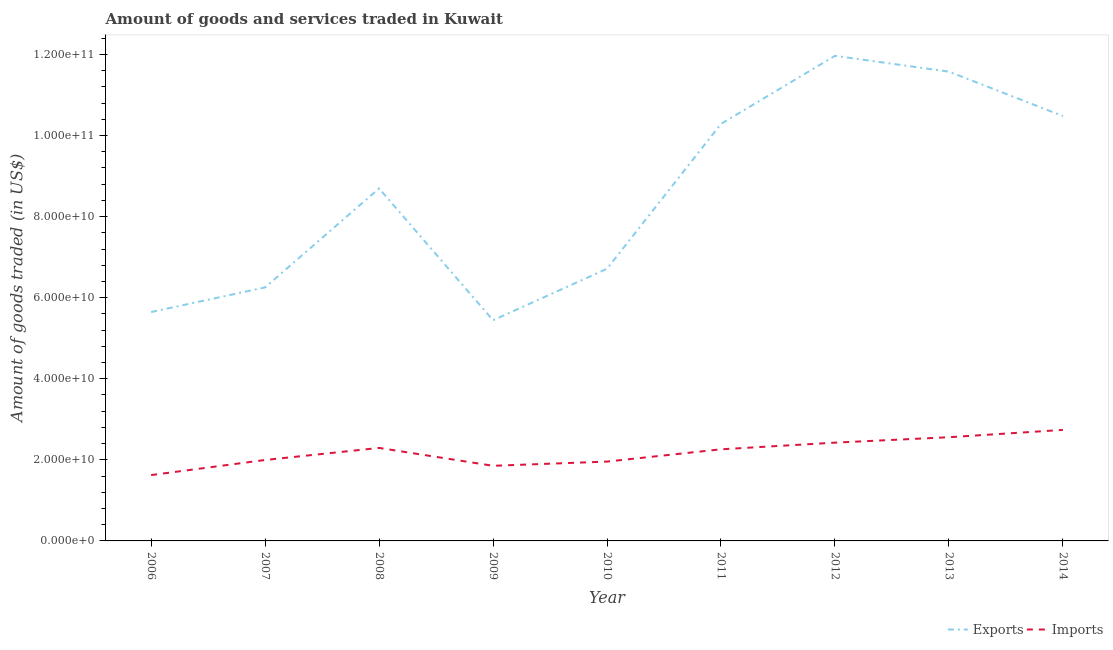How many different coloured lines are there?
Offer a very short reply. 2. Does the line corresponding to amount of goods exported intersect with the line corresponding to amount of goods imported?
Make the answer very short. No. What is the amount of goods imported in 2007?
Your answer should be very brief. 2.00e+1. Across all years, what is the maximum amount of goods exported?
Provide a short and direct response. 1.20e+11. Across all years, what is the minimum amount of goods imported?
Offer a very short reply. 1.62e+1. In which year was the amount of goods exported minimum?
Offer a very short reply. 2009. What is the total amount of goods imported in the graph?
Make the answer very short. 1.97e+11. What is the difference between the amount of goods imported in 2010 and that in 2011?
Offer a very short reply. -3.03e+09. What is the difference between the amount of goods exported in 2007 and the amount of goods imported in 2006?
Give a very brief answer. 4.63e+1. What is the average amount of goods exported per year?
Give a very brief answer. 8.56e+1. In the year 2014, what is the difference between the amount of goods imported and amount of goods exported?
Offer a very short reply. -7.74e+1. In how many years, is the amount of goods imported greater than 4000000000 US$?
Your answer should be very brief. 9. What is the ratio of the amount of goods imported in 2011 to that in 2012?
Provide a short and direct response. 0.93. What is the difference between the highest and the second highest amount of goods imported?
Provide a succinct answer. 1.81e+09. What is the difference between the highest and the lowest amount of goods exported?
Provide a short and direct response. 6.52e+1. In how many years, is the amount of goods exported greater than the average amount of goods exported taken over all years?
Make the answer very short. 5. Does the amount of goods exported monotonically increase over the years?
Make the answer very short. No. How many lines are there?
Offer a terse response. 2. Does the graph contain any zero values?
Keep it short and to the point. No. How many legend labels are there?
Your response must be concise. 2. How are the legend labels stacked?
Offer a terse response. Horizontal. What is the title of the graph?
Keep it short and to the point. Amount of goods and services traded in Kuwait. What is the label or title of the Y-axis?
Keep it short and to the point. Amount of goods traded (in US$). What is the Amount of goods traded (in US$) in Exports in 2006?
Ensure brevity in your answer.  5.65e+1. What is the Amount of goods traded (in US$) of Imports in 2006?
Provide a short and direct response. 1.62e+1. What is the Amount of goods traded (in US$) in Exports in 2007?
Make the answer very short. 6.25e+1. What is the Amount of goods traded (in US$) of Imports in 2007?
Your answer should be compact. 2.00e+1. What is the Amount of goods traded (in US$) of Exports in 2008?
Offer a very short reply. 8.69e+1. What is the Amount of goods traded (in US$) of Imports in 2008?
Give a very brief answer. 2.29e+1. What is the Amount of goods traded (in US$) in Exports in 2009?
Your answer should be very brief. 5.44e+1. What is the Amount of goods traded (in US$) in Imports in 2009?
Make the answer very short. 1.85e+1. What is the Amount of goods traded (in US$) of Exports in 2010?
Provide a short and direct response. 6.71e+1. What is the Amount of goods traded (in US$) of Imports in 2010?
Your response must be concise. 1.96e+1. What is the Amount of goods traded (in US$) of Exports in 2011?
Your answer should be compact. 1.03e+11. What is the Amount of goods traded (in US$) of Imports in 2011?
Provide a short and direct response. 2.26e+1. What is the Amount of goods traded (in US$) in Exports in 2012?
Your answer should be very brief. 1.20e+11. What is the Amount of goods traded (in US$) in Imports in 2012?
Keep it short and to the point. 2.42e+1. What is the Amount of goods traded (in US$) of Exports in 2013?
Give a very brief answer. 1.16e+11. What is the Amount of goods traded (in US$) of Imports in 2013?
Offer a terse response. 2.56e+1. What is the Amount of goods traded (in US$) of Exports in 2014?
Your answer should be compact. 1.05e+11. What is the Amount of goods traded (in US$) of Imports in 2014?
Your answer should be very brief. 2.74e+1. Across all years, what is the maximum Amount of goods traded (in US$) of Exports?
Offer a terse response. 1.20e+11. Across all years, what is the maximum Amount of goods traded (in US$) in Imports?
Provide a short and direct response. 2.74e+1. Across all years, what is the minimum Amount of goods traded (in US$) in Exports?
Your answer should be compact. 5.44e+1. Across all years, what is the minimum Amount of goods traded (in US$) of Imports?
Make the answer very short. 1.62e+1. What is the total Amount of goods traded (in US$) in Exports in the graph?
Your answer should be compact. 7.71e+11. What is the total Amount of goods traded (in US$) in Imports in the graph?
Give a very brief answer. 1.97e+11. What is the difference between the Amount of goods traded (in US$) of Exports in 2006 and that in 2007?
Keep it short and to the point. -6.07e+09. What is the difference between the Amount of goods traded (in US$) in Imports in 2006 and that in 2007?
Ensure brevity in your answer.  -3.72e+09. What is the difference between the Amount of goods traded (in US$) of Exports in 2006 and that in 2008?
Provide a short and direct response. -3.05e+1. What is the difference between the Amount of goods traded (in US$) of Imports in 2006 and that in 2008?
Your answer should be very brief. -6.70e+09. What is the difference between the Amount of goods traded (in US$) of Exports in 2006 and that in 2009?
Your answer should be compact. 2.03e+09. What is the difference between the Amount of goods traded (in US$) of Imports in 2006 and that in 2009?
Your answer should be compact. -2.29e+09. What is the difference between the Amount of goods traded (in US$) of Exports in 2006 and that in 2010?
Ensure brevity in your answer.  -1.07e+1. What is the difference between the Amount of goods traded (in US$) of Imports in 2006 and that in 2010?
Give a very brief answer. -3.33e+09. What is the difference between the Amount of goods traded (in US$) in Exports in 2006 and that in 2011?
Keep it short and to the point. -4.64e+1. What is the difference between the Amount of goods traded (in US$) in Imports in 2006 and that in 2011?
Make the answer very short. -6.36e+09. What is the difference between the Amount of goods traded (in US$) of Exports in 2006 and that in 2012?
Provide a short and direct response. -6.32e+1. What is the difference between the Amount of goods traded (in US$) in Imports in 2006 and that in 2012?
Your answer should be compact. -8.00e+09. What is the difference between the Amount of goods traded (in US$) in Exports in 2006 and that in 2013?
Give a very brief answer. -5.93e+1. What is the difference between the Amount of goods traded (in US$) of Imports in 2006 and that in 2013?
Your answer should be very brief. -9.34e+09. What is the difference between the Amount of goods traded (in US$) in Exports in 2006 and that in 2014?
Provide a succinct answer. -4.83e+1. What is the difference between the Amount of goods traded (in US$) of Imports in 2006 and that in 2014?
Your answer should be compact. -1.11e+1. What is the difference between the Amount of goods traded (in US$) in Exports in 2007 and that in 2008?
Your response must be concise. -2.44e+1. What is the difference between the Amount of goods traded (in US$) of Imports in 2007 and that in 2008?
Provide a succinct answer. -2.98e+09. What is the difference between the Amount of goods traded (in US$) of Exports in 2007 and that in 2009?
Your answer should be very brief. 8.10e+09. What is the difference between the Amount of goods traded (in US$) in Imports in 2007 and that in 2009?
Provide a succinct answer. 1.43e+09. What is the difference between the Amount of goods traded (in US$) of Exports in 2007 and that in 2010?
Your answer should be very brief. -4.60e+09. What is the difference between the Amount of goods traded (in US$) in Imports in 2007 and that in 2010?
Give a very brief answer. 3.93e+08. What is the difference between the Amount of goods traded (in US$) in Exports in 2007 and that in 2011?
Your response must be concise. -4.03e+1. What is the difference between the Amount of goods traded (in US$) of Imports in 2007 and that in 2011?
Offer a terse response. -2.64e+09. What is the difference between the Amount of goods traded (in US$) in Exports in 2007 and that in 2012?
Give a very brief answer. -5.71e+1. What is the difference between the Amount of goods traded (in US$) in Imports in 2007 and that in 2012?
Offer a terse response. -4.28e+09. What is the difference between the Amount of goods traded (in US$) in Exports in 2007 and that in 2013?
Make the answer very short. -5.32e+1. What is the difference between the Amount of goods traded (in US$) in Imports in 2007 and that in 2013?
Make the answer very short. -5.61e+09. What is the difference between the Amount of goods traded (in US$) in Exports in 2007 and that in 2014?
Your response must be concise. -4.23e+1. What is the difference between the Amount of goods traded (in US$) in Imports in 2007 and that in 2014?
Offer a very short reply. -7.42e+09. What is the difference between the Amount of goods traded (in US$) of Exports in 2008 and that in 2009?
Your answer should be compact. 3.25e+1. What is the difference between the Amount of goods traded (in US$) of Imports in 2008 and that in 2009?
Keep it short and to the point. 4.41e+09. What is the difference between the Amount of goods traded (in US$) in Exports in 2008 and that in 2010?
Keep it short and to the point. 1.98e+1. What is the difference between the Amount of goods traded (in US$) of Imports in 2008 and that in 2010?
Ensure brevity in your answer.  3.37e+09. What is the difference between the Amount of goods traded (in US$) in Exports in 2008 and that in 2011?
Your response must be concise. -1.59e+1. What is the difference between the Amount of goods traded (in US$) in Imports in 2008 and that in 2011?
Offer a very short reply. 3.42e+08. What is the difference between the Amount of goods traded (in US$) of Exports in 2008 and that in 2012?
Your response must be concise. -3.27e+1. What is the difference between the Amount of goods traded (in US$) in Imports in 2008 and that in 2012?
Give a very brief answer. -1.30e+09. What is the difference between the Amount of goods traded (in US$) in Exports in 2008 and that in 2013?
Ensure brevity in your answer.  -2.88e+1. What is the difference between the Amount of goods traded (in US$) of Imports in 2008 and that in 2013?
Your answer should be very brief. -2.64e+09. What is the difference between the Amount of goods traded (in US$) of Exports in 2008 and that in 2014?
Your answer should be very brief. -1.79e+1. What is the difference between the Amount of goods traded (in US$) in Imports in 2008 and that in 2014?
Ensure brevity in your answer.  -4.45e+09. What is the difference between the Amount of goods traded (in US$) of Exports in 2009 and that in 2010?
Make the answer very short. -1.27e+1. What is the difference between the Amount of goods traded (in US$) in Imports in 2009 and that in 2010?
Your response must be concise. -1.04e+09. What is the difference between the Amount of goods traded (in US$) in Exports in 2009 and that in 2011?
Provide a short and direct response. -4.84e+1. What is the difference between the Amount of goods traded (in US$) of Imports in 2009 and that in 2011?
Give a very brief answer. -4.07e+09. What is the difference between the Amount of goods traded (in US$) of Exports in 2009 and that in 2012?
Keep it short and to the point. -6.52e+1. What is the difference between the Amount of goods traded (in US$) in Imports in 2009 and that in 2012?
Make the answer very short. -5.71e+09. What is the difference between the Amount of goods traded (in US$) of Exports in 2009 and that in 2013?
Ensure brevity in your answer.  -6.13e+1. What is the difference between the Amount of goods traded (in US$) in Imports in 2009 and that in 2013?
Give a very brief answer. -7.05e+09. What is the difference between the Amount of goods traded (in US$) in Exports in 2009 and that in 2014?
Provide a succinct answer. -5.04e+1. What is the difference between the Amount of goods traded (in US$) of Imports in 2009 and that in 2014?
Provide a succinct answer. -8.86e+09. What is the difference between the Amount of goods traded (in US$) of Exports in 2010 and that in 2011?
Provide a short and direct response. -3.57e+1. What is the difference between the Amount of goods traded (in US$) of Imports in 2010 and that in 2011?
Provide a short and direct response. -3.03e+09. What is the difference between the Amount of goods traded (in US$) in Exports in 2010 and that in 2012?
Give a very brief answer. -5.25e+1. What is the difference between the Amount of goods traded (in US$) of Imports in 2010 and that in 2012?
Ensure brevity in your answer.  -4.67e+09. What is the difference between the Amount of goods traded (in US$) in Exports in 2010 and that in 2013?
Your response must be concise. -4.86e+1. What is the difference between the Amount of goods traded (in US$) in Imports in 2010 and that in 2013?
Make the answer very short. -6.01e+09. What is the difference between the Amount of goods traded (in US$) in Exports in 2010 and that in 2014?
Your response must be concise. -3.77e+1. What is the difference between the Amount of goods traded (in US$) of Imports in 2010 and that in 2014?
Provide a succinct answer. -7.82e+09. What is the difference between the Amount of goods traded (in US$) of Exports in 2011 and that in 2012?
Make the answer very short. -1.68e+1. What is the difference between the Amount of goods traded (in US$) of Imports in 2011 and that in 2012?
Give a very brief answer. -1.64e+09. What is the difference between the Amount of goods traded (in US$) of Exports in 2011 and that in 2013?
Make the answer very short. -1.29e+1. What is the difference between the Amount of goods traded (in US$) of Imports in 2011 and that in 2013?
Your answer should be compact. -2.98e+09. What is the difference between the Amount of goods traded (in US$) of Exports in 2011 and that in 2014?
Offer a terse response. -1.94e+09. What is the difference between the Amount of goods traded (in US$) in Imports in 2011 and that in 2014?
Provide a short and direct response. -4.79e+09. What is the difference between the Amount of goods traded (in US$) of Exports in 2012 and that in 2013?
Your answer should be very brief. 3.90e+09. What is the difference between the Amount of goods traded (in US$) in Imports in 2012 and that in 2013?
Provide a succinct answer. -1.33e+09. What is the difference between the Amount of goods traded (in US$) in Exports in 2012 and that in 2014?
Your answer should be very brief. 1.48e+1. What is the difference between the Amount of goods traded (in US$) of Imports in 2012 and that in 2014?
Make the answer very short. -3.14e+09. What is the difference between the Amount of goods traded (in US$) of Exports in 2013 and that in 2014?
Offer a very short reply. 1.10e+1. What is the difference between the Amount of goods traded (in US$) in Imports in 2013 and that in 2014?
Your answer should be compact. -1.81e+09. What is the difference between the Amount of goods traded (in US$) of Exports in 2006 and the Amount of goods traded (in US$) of Imports in 2007?
Provide a short and direct response. 3.65e+1. What is the difference between the Amount of goods traded (in US$) in Exports in 2006 and the Amount of goods traded (in US$) in Imports in 2008?
Your response must be concise. 3.35e+1. What is the difference between the Amount of goods traded (in US$) of Exports in 2006 and the Amount of goods traded (in US$) of Imports in 2009?
Make the answer very short. 3.79e+1. What is the difference between the Amount of goods traded (in US$) of Exports in 2006 and the Amount of goods traded (in US$) of Imports in 2010?
Ensure brevity in your answer.  3.69e+1. What is the difference between the Amount of goods traded (in US$) of Exports in 2006 and the Amount of goods traded (in US$) of Imports in 2011?
Give a very brief answer. 3.39e+1. What is the difference between the Amount of goods traded (in US$) in Exports in 2006 and the Amount of goods traded (in US$) in Imports in 2012?
Your response must be concise. 3.22e+1. What is the difference between the Amount of goods traded (in US$) in Exports in 2006 and the Amount of goods traded (in US$) in Imports in 2013?
Ensure brevity in your answer.  3.09e+1. What is the difference between the Amount of goods traded (in US$) in Exports in 2006 and the Amount of goods traded (in US$) in Imports in 2014?
Offer a terse response. 2.91e+1. What is the difference between the Amount of goods traded (in US$) in Exports in 2007 and the Amount of goods traded (in US$) in Imports in 2008?
Your answer should be very brief. 3.96e+1. What is the difference between the Amount of goods traded (in US$) of Exports in 2007 and the Amount of goods traded (in US$) of Imports in 2009?
Keep it short and to the point. 4.40e+1. What is the difference between the Amount of goods traded (in US$) of Exports in 2007 and the Amount of goods traded (in US$) of Imports in 2010?
Your response must be concise. 4.30e+1. What is the difference between the Amount of goods traded (in US$) in Exports in 2007 and the Amount of goods traded (in US$) in Imports in 2011?
Your answer should be compact. 3.99e+1. What is the difference between the Amount of goods traded (in US$) in Exports in 2007 and the Amount of goods traded (in US$) in Imports in 2012?
Your response must be concise. 3.83e+1. What is the difference between the Amount of goods traded (in US$) of Exports in 2007 and the Amount of goods traded (in US$) of Imports in 2013?
Your answer should be very brief. 3.69e+1. What is the difference between the Amount of goods traded (in US$) in Exports in 2007 and the Amount of goods traded (in US$) in Imports in 2014?
Keep it short and to the point. 3.51e+1. What is the difference between the Amount of goods traded (in US$) of Exports in 2008 and the Amount of goods traded (in US$) of Imports in 2009?
Give a very brief answer. 6.84e+1. What is the difference between the Amount of goods traded (in US$) of Exports in 2008 and the Amount of goods traded (in US$) of Imports in 2010?
Offer a very short reply. 6.74e+1. What is the difference between the Amount of goods traded (in US$) in Exports in 2008 and the Amount of goods traded (in US$) in Imports in 2011?
Provide a succinct answer. 6.43e+1. What is the difference between the Amount of goods traded (in US$) of Exports in 2008 and the Amount of goods traded (in US$) of Imports in 2012?
Provide a short and direct response. 6.27e+1. What is the difference between the Amount of goods traded (in US$) of Exports in 2008 and the Amount of goods traded (in US$) of Imports in 2013?
Keep it short and to the point. 6.14e+1. What is the difference between the Amount of goods traded (in US$) in Exports in 2008 and the Amount of goods traded (in US$) in Imports in 2014?
Provide a succinct answer. 5.96e+1. What is the difference between the Amount of goods traded (in US$) in Exports in 2009 and the Amount of goods traded (in US$) in Imports in 2010?
Your answer should be very brief. 3.49e+1. What is the difference between the Amount of goods traded (in US$) of Exports in 2009 and the Amount of goods traded (in US$) of Imports in 2011?
Your answer should be compact. 3.18e+1. What is the difference between the Amount of goods traded (in US$) of Exports in 2009 and the Amount of goods traded (in US$) of Imports in 2012?
Ensure brevity in your answer.  3.02e+1. What is the difference between the Amount of goods traded (in US$) of Exports in 2009 and the Amount of goods traded (in US$) of Imports in 2013?
Ensure brevity in your answer.  2.88e+1. What is the difference between the Amount of goods traded (in US$) in Exports in 2009 and the Amount of goods traded (in US$) in Imports in 2014?
Offer a terse response. 2.70e+1. What is the difference between the Amount of goods traded (in US$) of Exports in 2010 and the Amount of goods traded (in US$) of Imports in 2011?
Offer a very short reply. 4.45e+1. What is the difference between the Amount of goods traded (in US$) in Exports in 2010 and the Amount of goods traded (in US$) in Imports in 2012?
Give a very brief answer. 4.29e+1. What is the difference between the Amount of goods traded (in US$) of Exports in 2010 and the Amount of goods traded (in US$) of Imports in 2013?
Provide a succinct answer. 4.16e+1. What is the difference between the Amount of goods traded (in US$) in Exports in 2010 and the Amount of goods traded (in US$) in Imports in 2014?
Offer a very short reply. 3.97e+1. What is the difference between the Amount of goods traded (in US$) of Exports in 2011 and the Amount of goods traded (in US$) of Imports in 2012?
Ensure brevity in your answer.  7.86e+1. What is the difference between the Amount of goods traded (in US$) of Exports in 2011 and the Amount of goods traded (in US$) of Imports in 2013?
Provide a succinct answer. 7.73e+1. What is the difference between the Amount of goods traded (in US$) in Exports in 2011 and the Amount of goods traded (in US$) in Imports in 2014?
Keep it short and to the point. 7.55e+1. What is the difference between the Amount of goods traded (in US$) in Exports in 2012 and the Amount of goods traded (in US$) in Imports in 2013?
Provide a succinct answer. 9.41e+1. What is the difference between the Amount of goods traded (in US$) in Exports in 2012 and the Amount of goods traded (in US$) in Imports in 2014?
Ensure brevity in your answer.  9.23e+1. What is the difference between the Amount of goods traded (in US$) of Exports in 2013 and the Amount of goods traded (in US$) of Imports in 2014?
Make the answer very short. 8.84e+1. What is the average Amount of goods traded (in US$) in Exports per year?
Your answer should be compact. 8.56e+1. What is the average Amount of goods traded (in US$) of Imports per year?
Your response must be concise. 2.19e+1. In the year 2006, what is the difference between the Amount of goods traded (in US$) in Exports and Amount of goods traded (in US$) in Imports?
Offer a very short reply. 4.02e+1. In the year 2007, what is the difference between the Amount of goods traded (in US$) in Exports and Amount of goods traded (in US$) in Imports?
Provide a succinct answer. 4.26e+1. In the year 2008, what is the difference between the Amount of goods traded (in US$) in Exports and Amount of goods traded (in US$) in Imports?
Provide a succinct answer. 6.40e+1. In the year 2009, what is the difference between the Amount of goods traded (in US$) of Exports and Amount of goods traded (in US$) of Imports?
Your response must be concise. 3.59e+1. In the year 2010, what is the difference between the Amount of goods traded (in US$) of Exports and Amount of goods traded (in US$) of Imports?
Provide a succinct answer. 4.76e+1. In the year 2011, what is the difference between the Amount of goods traded (in US$) in Exports and Amount of goods traded (in US$) in Imports?
Provide a short and direct response. 8.03e+1. In the year 2012, what is the difference between the Amount of goods traded (in US$) of Exports and Amount of goods traded (in US$) of Imports?
Provide a succinct answer. 9.54e+1. In the year 2013, what is the difference between the Amount of goods traded (in US$) of Exports and Amount of goods traded (in US$) of Imports?
Provide a succinct answer. 9.02e+1. In the year 2014, what is the difference between the Amount of goods traded (in US$) of Exports and Amount of goods traded (in US$) of Imports?
Provide a succinct answer. 7.74e+1. What is the ratio of the Amount of goods traded (in US$) of Exports in 2006 to that in 2007?
Your answer should be compact. 0.9. What is the ratio of the Amount of goods traded (in US$) in Imports in 2006 to that in 2007?
Offer a terse response. 0.81. What is the ratio of the Amount of goods traded (in US$) in Exports in 2006 to that in 2008?
Your answer should be very brief. 0.65. What is the ratio of the Amount of goods traded (in US$) in Imports in 2006 to that in 2008?
Give a very brief answer. 0.71. What is the ratio of the Amount of goods traded (in US$) in Exports in 2006 to that in 2009?
Your answer should be very brief. 1.04. What is the ratio of the Amount of goods traded (in US$) of Imports in 2006 to that in 2009?
Provide a succinct answer. 0.88. What is the ratio of the Amount of goods traded (in US$) in Exports in 2006 to that in 2010?
Offer a very short reply. 0.84. What is the ratio of the Amount of goods traded (in US$) in Imports in 2006 to that in 2010?
Provide a short and direct response. 0.83. What is the ratio of the Amount of goods traded (in US$) in Exports in 2006 to that in 2011?
Give a very brief answer. 0.55. What is the ratio of the Amount of goods traded (in US$) of Imports in 2006 to that in 2011?
Ensure brevity in your answer.  0.72. What is the ratio of the Amount of goods traded (in US$) of Exports in 2006 to that in 2012?
Give a very brief answer. 0.47. What is the ratio of the Amount of goods traded (in US$) in Imports in 2006 to that in 2012?
Offer a very short reply. 0.67. What is the ratio of the Amount of goods traded (in US$) in Exports in 2006 to that in 2013?
Make the answer very short. 0.49. What is the ratio of the Amount of goods traded (in US$) of Imports in 2006 to that in 2013?
Give a very brief answer. 0.64. What is the ratio of the Amount of goods traded (in US$) in Exports in 2006 to that in 2014?
Keep it short and to the point. 0.54. What is the ratio of the Amount of goods traded (in US$) in Imports in 2006 to that in 2014?
Your response must be concise. 0.59. What is the ratio of the Amount of goods traded (in US$) of Exports in 2007 to that in 2008?
Make the answer very short. 0.72. What is the ratio of the Amount of goods traded (in US$) of Imports in 2007 to that in 2008?
Provide a succinct answer. 0.87. What is the ratio of the Amount of goods traded (in US$) in Exports in 2007 to that in 2009?
Provide a short and direct response. 1.15. What is the ratio of the Amount of goods traded (in US$) of Imports in 2007 to that in 2009?
Your answer should be compact. 1.08. What is the ratio of the Amount of goods traded (in US$) of Exports in 2007 to that in 2010?
Offer a terse response. 0.93. What is the ratio of the Amount of goods traded (in US$) in Imports in 2007 to that in 2010?
Offer a very short reply. 1.02. What is the ratio of the Amount of goods traded (in US$) in Exports in 2007 to that in 2011?
Provide a succinct answer. 0.61. What is the ratio of the Amount of goods traded (in US$) of Imports in 2007 to that in 2011?
Your response must be concise. 0.88. What is the ratio of the Amount of goods traded (in US$) in Exports in 2007 to that in 2012?
Your response must be concise. 0.52. What is the ratio of the Amount of goods traded (in US$) in Imports in 2007 to that in 2012?
Make the answer very short. 0.82. What is the ratio of the Amount of goods traded (in US$) in Exports in 2007 to that in 2013?
Keep it short and to the point. 0.54. What is the ratio of the Amount of goods traded (in US$) of Imports in 2007 to that in 2013?
Provide a succinct answer. 0.78. What is the ratio of the Amount of goods traded (in US$) of Exports in 2007 to that in 2014?
Offer a very short reply. 0.6. What is the ratio of the Amount of goods traded (in US$) of Imports in 2007 to that in 2014?
Your answer should be compact. 0.73. What is the ratio of the Amount of goods traded (in US$) of Exports in 2008 to that in 2009?
Make the answer very short. 1.6. What is the ratio of the Amount of goods traded (in US$) in Imports in 2008 to that in 2009?
Make the answer very short. 1.24. What is the ratio of the Amount of goods traded (in US$) of Exports in 2008 to that in 2010?
Give a very brief answer. 1.3. What is the ratio of the Amount of goods traded (in US$) in Imports in 2008 to that in 2010?
Provide a succinct answer. 1.17. What is the ratio of the Amount of goods traded (in US$) of Exports in 2008 to that in 2011?
Provide a short and direct response. 0.85. What is the ratio of the Amount of goods traded (in US$) in Imports in 2008 to that in 2011?
Ensure brevity in your answer.  1.02. What is the ratio of the Amount of goods traded (in US$) of Exports in 2008 to that in 2012?
Provide a short and direct response. 0.73. What is the ratio of the Amount of goods traded (in US$) of Imports in 2008 to that in 2012?
Give a very brief answer. 0.95. What is the ratio of the Amount of goods traded (in US$) in Exports in 2008 to that in 2013?
Your answer should be compact. 0.75. What is the ratio of the Amount of goods traded (in US$) in Imports in 2008 to that in 2013?
Make the answer very short. 0.9. What is the ratio of the Amount of goods traded (in US$) in Exports in 2008 to that in 2014?
Provide a succinct answer. 0.83. What is the ratio of the Amount of goods traded (in US$) of Imports in 2008 to that in 2014?
Ensure brevity in your answer.  0.84. What is the ratio of the Amount of goods traded (in US$) of Exports in 2009 to that in 2010?
Your answer should be very brief. 0.81. What is the ratio of the Amount of goods traded (in US$) in Imports in 2009 to that in 2010?
Ensure brevity in your answer.  0.95. What is the ratio of the Amount of goods traded (in US$) of Exports in 2009 to that in 2011?
Keep it short and to the point. 0.53. What is the ratio of the Amount of goods traded (in US$) of Imports in 2009 to that in 2011?
Make the answer very short. 0.82. What is the ratio of the Amount of goods traded (in US$) in Exports in 2009 to that in 2012?
Your answer should be very brief. 0.45. What is the ratio of the Amount of goods traded (in US$) of Imports in 2009 to that in 2012?
Give a very brief answer. 0.76. What is the ratio of the Amount of goods traded (in US$) in Exports in 2009 to that in 2013?
Keep it short and to the point. 0.47. What is the ratio of the Amount of goods traded (in US$) in Imports in 2009 to that in 2013?
Keep it short and to the point. 0.72. What is the ratio of the Amount of goods traded (in US$) in Exports in 2009 to that in 2014?
Make the answer very short. 0.52. What is the ratio of the Amount of goods traded (in US$) of Imports in 2009 to that in 2014?
Offer a very short reply. 0.68. What is the ratio of the Amount of goods traded (in US$) in Exports in 2010 to that in 2011?
Provide a short and direct response. 0.65. What is the ratio of the Amount of goods traded (in US$) of Imports in 2010 to that in 2011?
Give a very brief answer. 0.87. What is the ratio of the Amount of goods traded (in US$) of Exports in 2010 to that in 2012?
Ensure brevity in your answer.  0.56. What is the ratio of the Amount of goods traded (in US$) of Imports in 2010 to that in 2012?
Your answer should be very brief. 0.81. What is the ratio of the Amount of goods traded (in US$) of Exports in 2010 to that in 2013?
Keep it short and to the point. 0.58. What is the ratio of the Amount of goods traded (in US$) in Imports in 2010 to that in 2013?
Offer a terse response. 0.77. What is the ratio of the Amount of goods traded (in US$) in Exports in 2010 to that in 2014?
Make the answer very short. 0.64. What is the ratio of the Amount of goods traded (in US$) in Imports in 2010 to that in 2014?
Give a very brief answer. 0.71. What is the ratio of the Amount of goods traded (in US$) in Exports in 2011 to that in 2012?
Keep it short and to the point. 0.86. What is the ratio of the Amount of goods traded (in US$) of Imports in 2011 to that in 2012?
Offer a very short reply. 0.93. What is the ratio of the Amount of goods traded (in US$) of Exports in 2011 to that in 2013?
Provide a succinct answer. 0.89. What is the ratio of the Amount of goods traded (in US$) in Imports in 2011 to that in 2013?
Provide a short and direct response. 0.88. What is the ratio of the Amount of goods traded (in US$) in Exports in 2011 to that in 2014?
Offer a terse response. 0.98. What is the ratio of the Amount of goods traded (in US$) in Imports in 2011 to that in 2014?
Provide a succinct answer. 0.83. What is the ratio of the Amount of goods traded (in US$) of Exports in 2012 to that in 2013?
Make the answer very short. 1.03. What is the ratio of the Amount of goods traded (in US$) of Imports in 2012 to that in 2013?
Keep it short and to the point. 0.95. What is the ratio of the Amount of goods traded (in US$) of Exports in 2012 to that in 2014?
Make the answer very short. 1.14. What is the ratio of the Amount of goods traded (in US$) in Imports in 2012 to that in 2014?
Ensure brevity in your answer.  0.89. What is the ratio of the Amount of goods traded (in US$) in Exports in 2013 to that in 2014?
Offer a terse response. 1.1. What is the ratio of the Amount of goods traded (in US$) of Imports in 2013 to that in 2014?
Provide a short and direct response. 0.93. What is the difference between the highest and the second highest Amount of goods traded (in US$) in Exports?
Ensure brevity in your answer.  3.90e+09. What is the difference between the highest and the second highest Amount of goods traded (in US$) in Imports?
Your response must be concise. 1.81e+09. What is the difference between the highest and the lowest Amount of goods traded (in US$) of Exports?
Your answer should be very brief. 6.52e+1. What is the difference between the highest and the lowest Amount of goods traded (in US$) in Imports?
Offer a very short reply. 1.11e+1. 